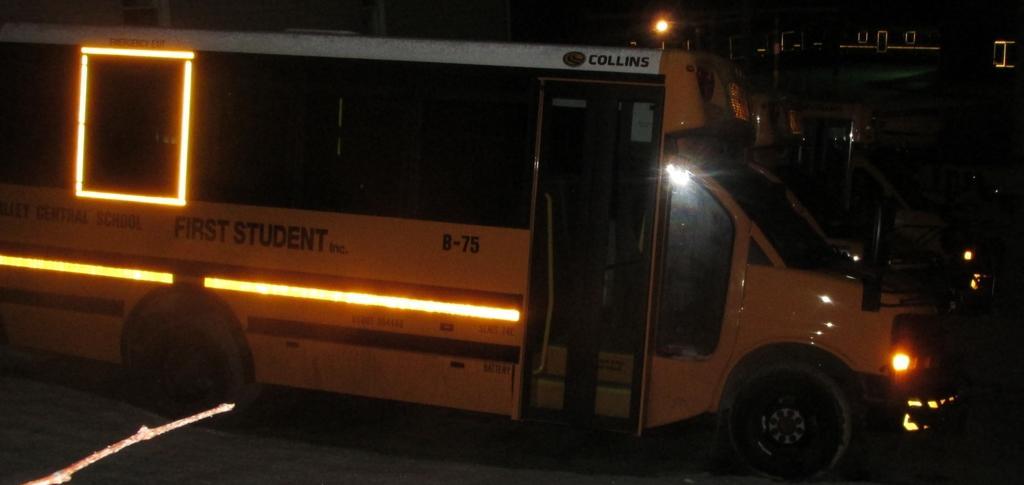Describe this image in one or two sentences. In this picture I can see a mini bus and I can see few lights, it looks like a school bus and looks like a building in the bath and I can see dark background. 